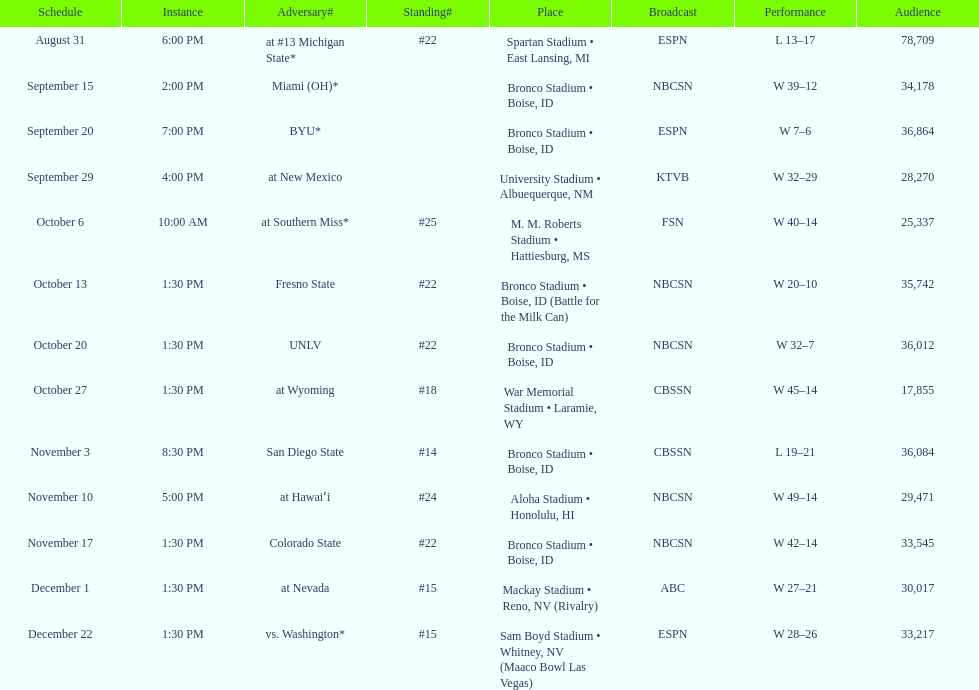Add up the total number of points scored in the last wins for boise state. 146. 